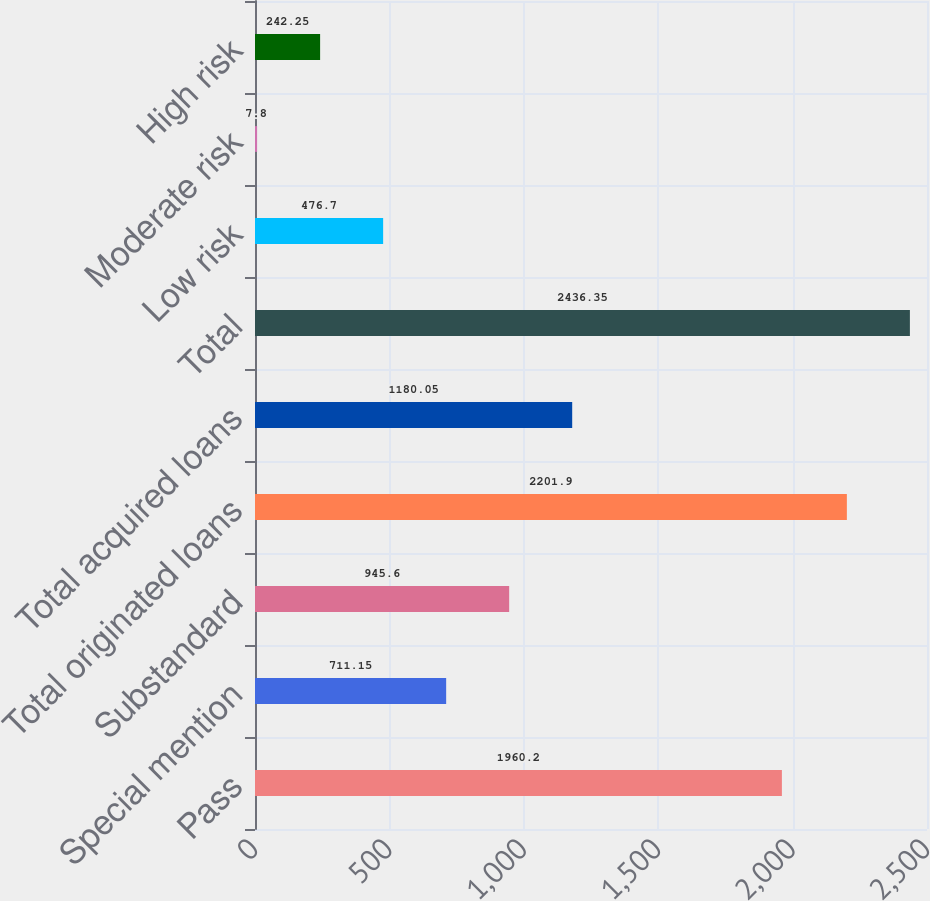Convert chart to OTSL. <chart><loc_0><loc_0><loc_500><loc_500><bar_chart><fcel>Pass<fcel>Special mention<fcel>Substandard<fcel>Total originated loans<fcel>Total acquired loans<fcel>Total<fcel>Low risk<fcel>Moderate risk<fcel>High risk<nl><fcel>1960.2<fcel>711.15<fcel>945.6<fcel>2201.9<fcel>1180.05<fcel>2436.35<fcel>476.7<fcel>7.8<fcel>242.25<nl></chart> 